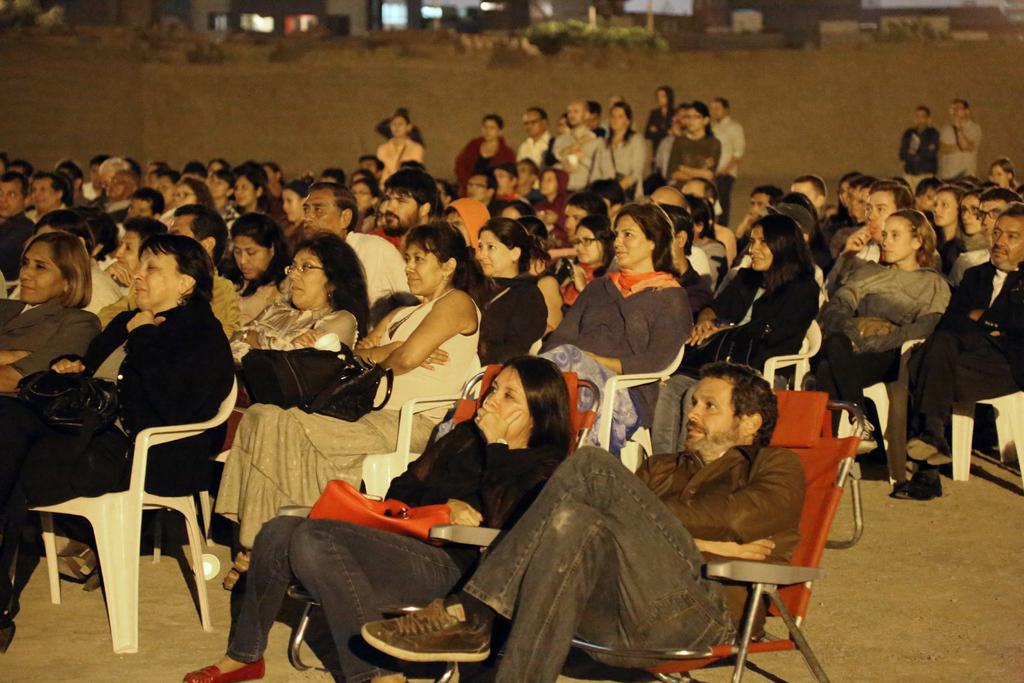What are the people in the image doing? There are groups of people sitting and standing in the image. What can be seen in the background of the image? There are buildings and trees in the background of the image. What is the surface on which the people are sitting and standing? There is a ground visible in the image. What type of doctor can be seen treating a bear in the image? There is no bear or doctor present in the image. How many ducks are visible in the image? There are no ducks present in the image. 